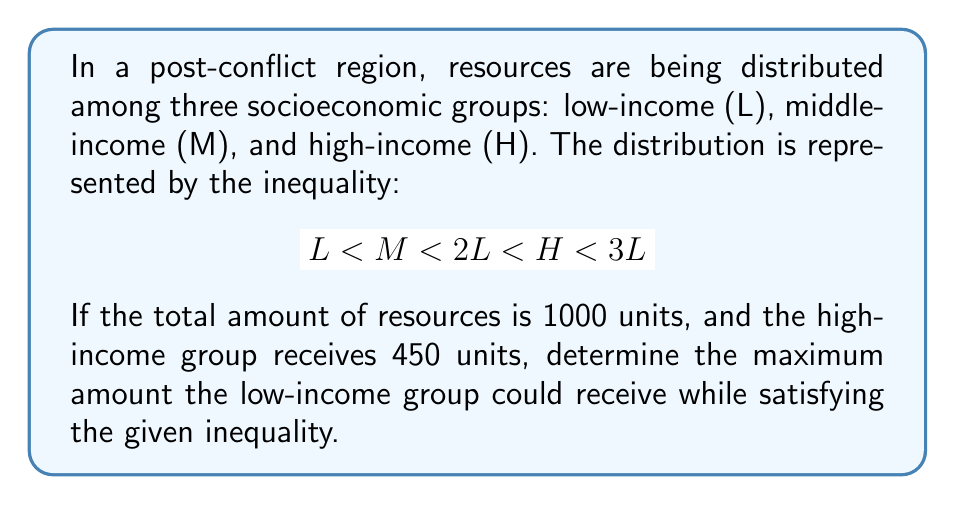Show me your answer to this math problem. Let's approach this step-by-step:

1) We know that $H = 450$ units.

2) From the inequality, we can see that $H < 3L$. This means:
   $$ 450 < 3L $$
   $$ L > 150 $$

3) We also know that $2L < H$. This means:
   $$ 2L < 450 $$
   $$ L < 225 $$

4) Combining steps 2 and 3, we get:
   $$ 150 < L < 225 $$

5) To find the maximum value of $L$, we need to consider the total resources and the minimum values for $M$ and $H$:
   - Total resources = 1000 units
   - $H = 450$ units
   - $M$ must be greater than $L$ but less than $2L$

6) Let's express $M$ in terms of $L$:
   $$ L < M < 2L $$
   We can represent $M$ as $L + x$, where $0 < x < L$

7) Now we can set up an equation:
   $$ L + (L + x) + 450 = 1000 $$
   $$ 2L + x = 550 $$

8) To maximize $L$, we need to minimize $x$. The smallest possible value for $x$ is just slightly above 0.

9) Therefore, the maximum value of $L$ is just slightly less than:
   $$ 2L = 550 $$
   $$ L = 275 $$

10) However, this violates the condition $L < 225$ from step 3.

11) Thus, the maximum value of $L$ that satisfies all conditions is 224.99 (or any value arbitrarily close to, but less than, 225).
Answer: The maximum amount the low-income group could receive is 224.99 units (or any value arbitrarily close to, but less than, 225 units). 